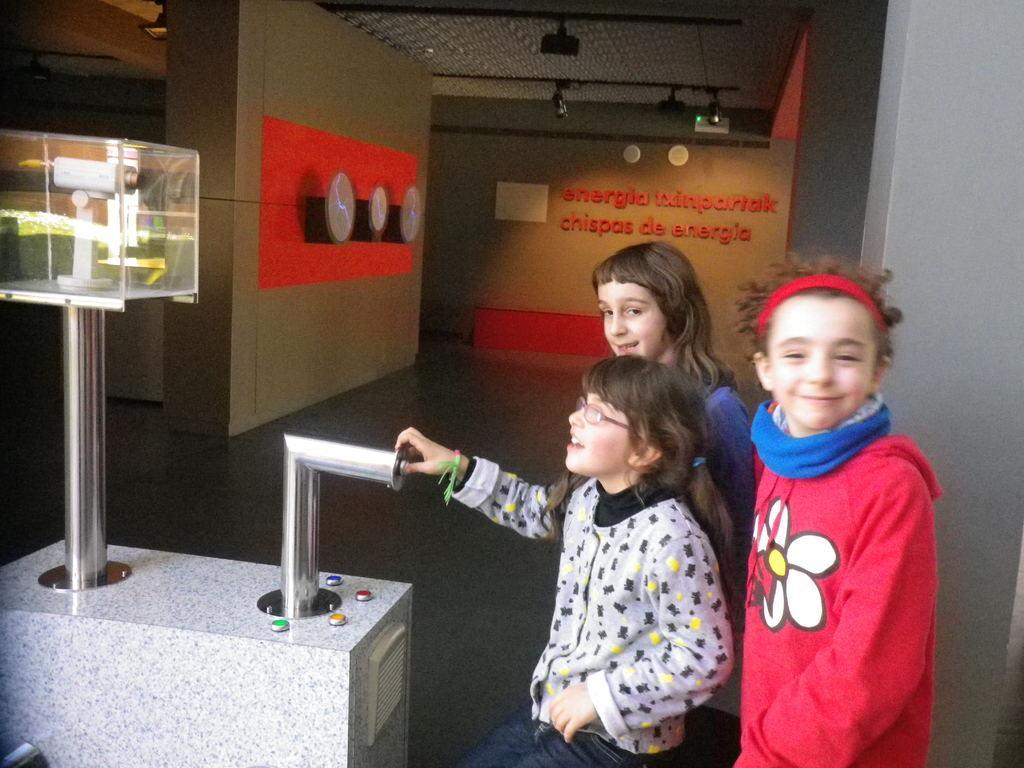In one or two sentences, can you explain what this image depicts? This image consists of three children. It looks like it is clicked in a room. In the front, there is a machine. In the background, there are walls. At the bottom, there is a floor. 